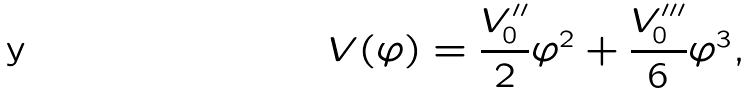<formula> <loc_0><loc_0><loc_500><loc_500>V ( \varphi ) = \frac { V ^ { \prime \prime } _ { 0 } } { 2 } \varphi ^ { 2 } + \frac { V ^ { \prime \prime \prime } _ { 0 } } { 6 } \varphi ^ { 3 } ,</formula> 